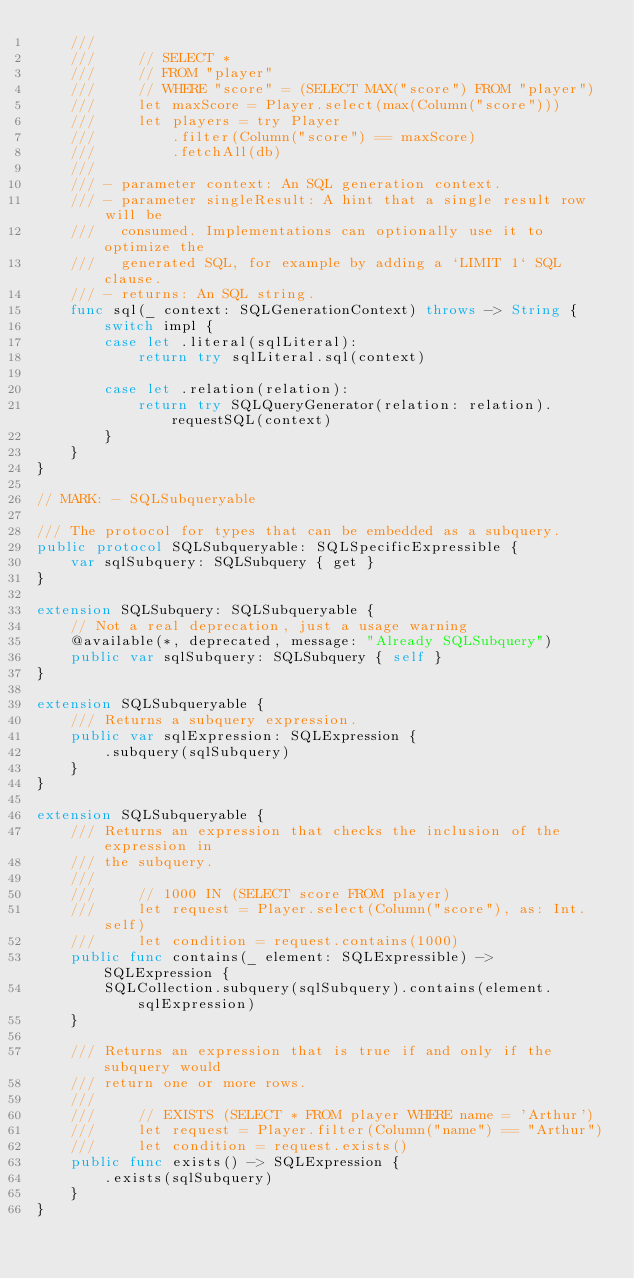Convert code to text. <code><loc_0><loc_0><loc_500><loc_500><_Swift_>    ///
    ///     // SELECT *
    ///     // FROM "player"
    ///     // WHERE "score" = (SELECT MAX("score") FROM "player")
    ///     let maxScore = Player.select(max(Column("score")))
    ///     let players = try Player
    ///         .filter(Column("score") == maxScore)
    ///         .fetchAll(db)
    ///
    /// - parameter context: An SQL generation context.
    /// - parameter singleResult: A hint that a single result row will be
    ///   consumed. Implementations can optionally use it to optimize the
    ///   generated SQL, for example by adding a `LIMIT 1` SQL clause.
    /// - returns: An SQL string.
    func sql(_ context: SQLGenerationContext) throws -> String {
        switch impl {
        case let .literal(sqlLiteral):
            return try sqlLiteral.sql(context)
            
        case let .relation(relation):
            return try SQLQueryGenerator(relation: relation).requestSQL(context)
        }
    }
}

// MARK: - SQLSubqueryable

/// The protocol for types that can be embedded as a subquery.
public protocol SQLSubqueryable: SQLSpecificExpressible {
    var sqlSubquery: SQLSubquery { get }
}

extension SQLSubquery: SQLSubqueryable {
    // Not a real deprecation, just a usage warning
    @available(*, deprecated, message: "Already SQLSubquery")
    public var sqlSubquery: SQLSubquery { self }
}

extension SQLSubqueryable {
    /// Returns a subquery expression.
    public var sqlExpression: SQLExpression {
        .subquery(sqlSubquery)
    }
}

extension SQLSubqueryable {
    /// Returns an expression that checks the inclusion of the expression in
    /// the subquery.
    ///
    ///     // 1000 IN (SELECT score FROM player)
    ///     let request = Player.select(Column("score"), as: Int.self)
    ///     let condition = request.contains(1000)
    public func contains(_ element: SQLExpressible) -> SQLExpression {
        SQLCollection.subquery(sqlSubquery).contains(element.sqlExpression)
    }
    
    /// Returns an expression that is true if and only if the subquery would
    /// return one or more rows.
    ///
    ///     // EXISTS (SELECT * FROM player WHERE name = 'Arthur')
    ///     let request = Player.filter(Column("name") == "Arthur")
    ///     let condition = request.exists()
    public func exists() -> SQLExpression {
        .exists(sqlSubquery)
    }
}
</code> 